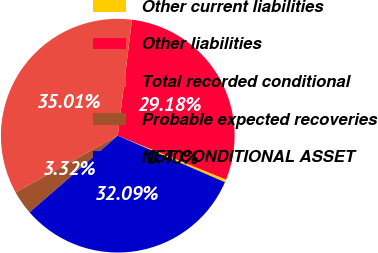Convert chart to OTSL. <chart><loc_0><loc_0><loc_500><loc_500><pie_chart><fcel>Other current liabilities<fcel>Other liabilities<fcel>Total recorded conditional<fcel>Probable expected recoveries<fcel>NET CONDITIONAL ASSET<nl><fcel>0.4%<fcel>29.18%<fcel>35.01%<fcel>3.32%<fcel>32.09%<nl></chart> 